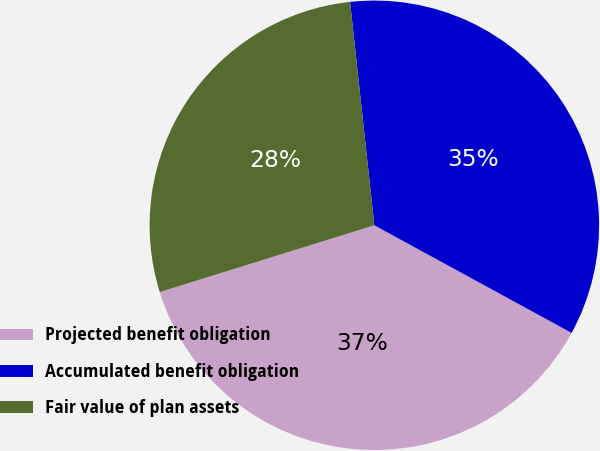<chart> <loc_0><loc_0><loc_500><loc_500><pie_chart><fcel>Projected benefit obligation<fcel>Accumulated benefit obligation<fcel>Fair value of plan assets<nl><fcel>37.25%<fcel>34.67%<fcel>28.08%<nl></chart> 